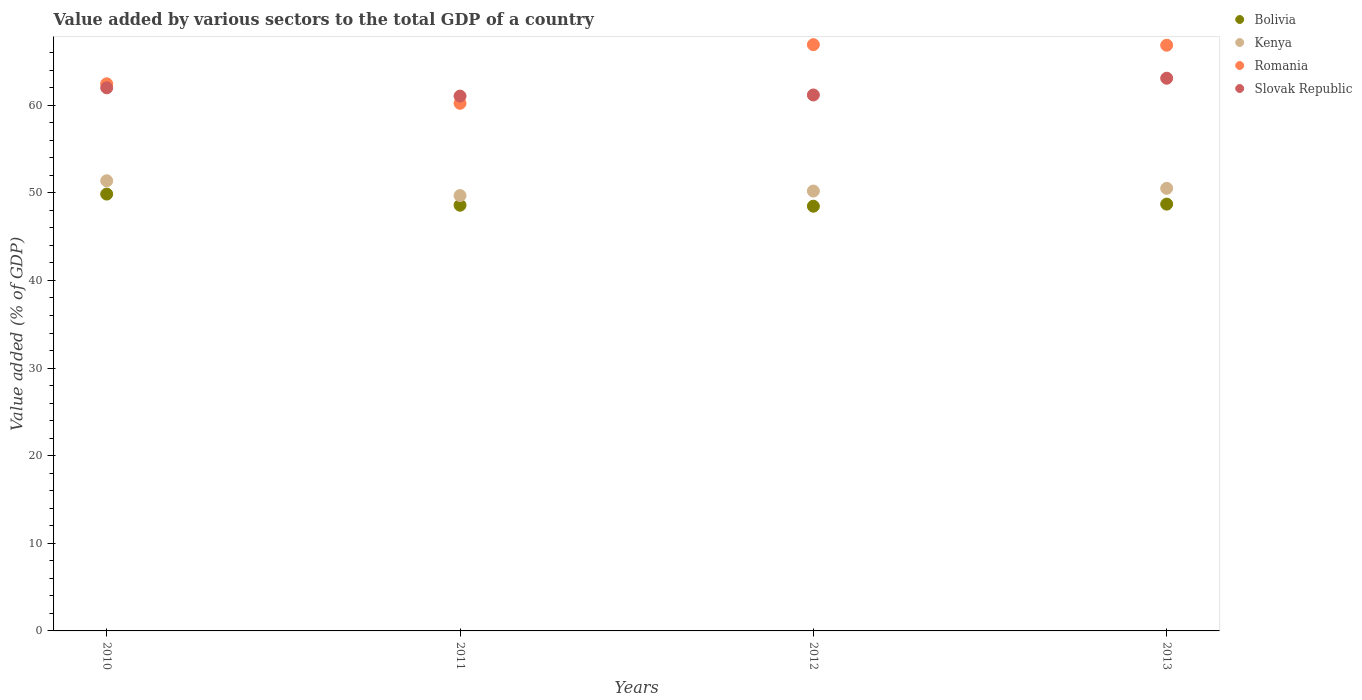How many different coloured dotlines are there?
Provide a succinct answer. 4. Is the number of dotlines equal to the number of legend labels?
Offer a very short reply. Yes. What is the value added by various sectors to the total GDP in Kenya in 2011?
Your response must be concise. 49.68. Across all years, what is the maximum value added by various sectors to the total GDP in Kenya?
Offer a terse response. 51.38. Across all years, what is the minimum value added by various sectors to the total GDP in Kenya?
Offer a very short reply. 49.68. In which year was the value added by various sectors to the total GDP in Slovak Republic maximum?
Provide a short and direct response. 2013. In which year was the value added by various sectors to the total GDP in Slovak Republic minimum?
Provide a short and direct response. 2011. What is the total value added by various sectors to the total GDP in Kenya in the graph?
Provide a short and direct response. 201.77. What is the difference between the value added by various sectors to the total GDP in Bolivia in 2011 and that in 2013?
Keep it short and to the point. -0.12. What is the difference between the value added by various sectors to the total GDP in Kenya in 2011 and the value added by various sectors to the total GDP in Romania in 2010?
Offer a very short reply. -12.75. What is the average value added by various sectors to the total GDP in Kenya per year?
Offer a terse response. 50.44. In the year 2010, what is the difference between the value added by various sectors to the total GDP in Romania and value added by various sectors to the total GDP in Kenya?
Offer a very short reply. 11.06. What is the ratio of the value added by various sectors to the total GDP in Romania in 2011 to that in 2013?
Ensure brevity in your answer.  0.9. Is the value added by various sectors to the total GDP in Slovak Republic in 2011 less than that in 2012?
Provide a succinct answer. Yes. Is the difference between the value added by various sectors to the total GDP in Romania in 2012 and 2013 greater than the difference between the value added by various sectors to the total GDP in Kenya in 2012 and 2013?
Offer a terse response. Yes. What is the difference between the highest and the second highest value added by various sectors to the total GDP in Bolivia?
Provide a short and direct response. 1.15. What is the difference between the highest and the lowest value added by various sectors to the total GDP in Kenya?
Offer a very short reply. 1.69. In how many years, is the value added by various sectors to the total GDP in Romania greater than the average value added by various sectors to the total GDP in Romania taken over all years?
Make the answer very short. 2. Is it the case that in every year, the sum of the value added by various sectors to the total GDP in Slovak Republic and value added by various sectors to the total GDP in Kenya  is greater than the value added by various sectors to the total GDP in Romania?
Keep it short and to the point. Yes. Does the value added by various sectors to the total GDP in Slovak Republic monotonically increase over the years?
Your response must be concise. No. How many dotlines are there?
Keep it short and to the point. 4. What is the difference between two consecutive major ticks on the Y-axis?
Your response must be concise. 10. Does the graph contain any zero values?
Your response must be concise. No. Where does the legend appear in the graph?
Offer a very short reply. Top right. How many legend labels are there?
Your response must be concise. 4. What is the title of the graph?
Your answer should be very brief. Value added by various sectors to the total GDP of a country. What is the label or title of the Y-axis?
Your answer should be compact. Value added (% of GDP). What is the Value added (% of GDP) of Bolivia in 2010?
Provide a short and direct response. 49.86. What is the Value added (% of GDP) in Kenya in 2010?
Your answer should be very brief. 51.38. What is the Value added (% of GDP) of Romania in 2010?
Your answer should be compact. 62.44. What is the Value added (% of GDP) of Slovak Republic in 2010?
Make the answer very short. 61.98. What is the Value added (% of GDP) of Bolivia in 2011?
Your answer should be very brief. 48.58. What is the Value added (% of GDP) in Kenya in 2011?
Give a very brief answer. 49.68. What is the Value added (% of GDP) of Romania in 2011?
Offer a terse response. 60.21. What is the Value added (% of GDP) of Slovak Republic in 2011?
Provide a short and direct response. 61.04. What is the Value added (% of GDP) in Bolivia in 2012?
Offer a terse response. 48.47. What is the Value added (% of GDP) of Kenya in 2012?
Offer a very short reply. 50.2. What is the Value added (% of GDP) of Romania in 2012?
Ensure brevity in your answer.  66.91. What is the Value added (% of GDP) in Slovak Republic in 2012?
Make the answer very short. 61.17. What is the Value added (% of GDP) in Bolivia in 2013?
Give a very brief answer. 48.71. What is the Value added (% of GDP) in Kenya in 2013?
Your answer should be very brief. 50.51. What is the Value added (% of GDP) in Romania in 2013?
Your response must be concise. 66.84. What is the Value added (% of GDP) of Slovak Republic in 2013?
Your answer should be compact. 63.08. Across all years, what is the maximum Value added (% of GDP) in Bolivia?
Keep it short and to the point. 49.86. Across all years, what is the maximum Value added (% of GDP) of Kenya?
Offer a very short reply. 51.38. Across all years, what is the maximum Value added (% of GDP) in Romania?
Ensure brevity in your answer.  66.91. Across all years, what is the maximum Value added (% of GDP) of Slovak Republic?
Your answer should be very brief. 63.08. Across all years, what is the minimum Value added (% of GDP) of Bolivia?
Provide a succinct answer. 48.47. Across all years, what is the minimum Value added (% of GDP) of Kenya?
Offer a terse response. 49.68. Across all years, what is the minimum Value added (% of GDP) in Romania?
Keep it short and to the point. 60.21. Across all years, what is the minimum Value added (% of GDP) of Slovak Republic?
Ensure brevity in your answer.  61.04. What is the total Value added (% of GDP) in Bolivia in the graph?
Your answer should be very brief. 195.62. What is the total Value added (% of GDP) of Kenya in the graph?
Provide a succinct answer. 201.77. What is the total Value added (% of GDP) in Romania in the graph?
Keep it short and to the point. 256.41. What is the total Value added (% of GDP) in Slovak Republic in the graph?
Provide a short and direct response. 247.27. What is the difference between the Value added (% of GDP) in Bolivia in 2010 and that in 2011?
Offer a terse response. 1.27. What is the difference between the Value added (% of GDP) of Kenya in 2010 and that in 2011?
Ensure brevity in your answer.  1.69. What is the difference between the Value added (% of GDP) of Romania in 2010 and that in 2011?
Make the answer very short. 2.23. What is the difference between the Value added (% of GDP) of Slovak Republic in 2010 and that in 2011?
Give a very brief answer. 0.94. What is the difference between the Value added (% of GDP) of Bolivia in 2010 and that in 2012?
Offer a terse response. 1.39. What is the difference between the Value added (% of GDP) in Kenya in 2010 and that in 2012?
Offer a terse response. 1.17. What is the difference between the Value added (% of GDP) in Romania in 2010 and that in 2012?
Give a very brief answer. -4.47. What is the difference between the Value added (% of GDP) of Slovak Republic in 2010 and that in 2012?
Ensure brevity in your answer.  0.82. What is the difference between the Value added (% of GDP) in Bolivia in 2010 and that in 2013?
Keep it short and to the point. 1.15. What is the difference between the Value added (% of GDP) in Kenya in 2010 and that in 2013?
Your answer should be compact. 0.86. What is the difference between the Value added (% of GDP) in Romania in 2010 and that in 2013?
Give a very brief answer. -4.4. What is the difference between the Value added (% of GDP) in Slovak Republic in 2010 and that in 2013?
Provide a short and direct response. -1.09. What is the difference between the Value added (% of GDP) of Bolivia in 2011 and that in 2012?
Your answer should be very brief. 0.11. What is the difference between the Value added (% of GDP) in Kenya in 2011 and that in 2012?
Ensure brevity in your answer.  -0.52. What is the difference between the Value added (% of GDP) in Romania in 2011 and that in 2012?
Keep it short and to the point. -6.69. What is the difference between the Value added (% of GDP) of Slovak Republic in 2011 and that in 2012?
Offer a very short reply. -0.13. What is the difference between the Value added (% of GDP) in Bolivia in 2011 and that in 2013?
Offer a very short reply. -0.12. What is the difference between the Value added (% of GDP) of Kenya in 2011 and that in 2013?
Your answer should be compact. -0.83. What is the difference between the Value added (% of GDP) of Romania in 2011 and that in 2013?
Offer a terse response. -6.63. What is the difference between the Value added (% of GDP) in Slovak Republic in 2011 and that in 2013?
Your response must be concise. -2.04. What is the difference between the Value added (% of GDP) in Bolivia in 2012 and that in 2013?
Provide a short and direct response. -0.24. What is the difference between the Value added (% of GDP) of Kenya in 2012 and that in 2013?
Your answer should be compact. -0.31. What is the difference between the Value added (% of GDP) in Romania in 2012 and that in 2013?
Your answer should be compact. 0.07. What is the difference between the Value added (% of GDP) of Slovak Republic in 2012 and that in 2013?
Offer a very short reply. -1.91. What is the difference between the Value added (% of GDP) in Bolivia in 2010 and the Value added (% of GDP) in Kenya in 2011?
Your response must be concise. 0.17. What is the difference between the Value added (% of GDP) in Bolivia in 2010 and the Value added (% of GDP) in Romania in 2011?
Provide a succinct answer. -10.36. What is the difference between the Value added (% of GDP) in Bolivia in 2010 and the Value added (% of GDP) in Slovak Republic in 2011?
Provide a short and direct response. -11.18. What is the difference between the Value added (% of GDP) of Kenya in 2010 and the Value added (% of GDP) of Romania in 2011?
Your answer should be compact. -8.84. What is the difference between the Value added (% of GDP) in Kenya in 2010 and the Value added (% of GDP) in Slovak Republic in 2011?
Keep it short and to the point. -9.66. What is the difference between the Value added (% of GDP) in Romania in 2010 and the Value added (% of GDP) in Slovak Republic in 2011?
Give a very brief answer. 1.4. What is the difference between the Value added (% of GDP) in Bolivia in 2010 and the Value added (% of GDP) in Kenya in 2012?
Provide a short and direct response. -0.35. What is the difference between the Value added (% of GDP) in Bolivia in 2010 and the Value added (% of GDP) in Romania in 2012?
Provide a succinct answer. -17.05. What is the difference between the Value added (% of GDP) of Bolivia in 2010 and the Value added (% of GDP) of Slovak Republic in 2012?
Your response must be concise. -11.31. What is the difference between the Value added (% of GDP) in Kenya in 2010 and the Value added (% of GDP) in Romania in 2012?
Your answer should be very brief. -15.53. What is the difference between the Value added (% of GDP) in Kenya in 2010 and the Value added (% of GDP) in Slovak Republic in 2012?
Give a very brief answer. -9.79. What is the difference between the Value added (% of GDP) in Romania in 2010 and the Value added (% of GDP) in Slovak Republic in 2012?
Your response must be concise. 1.27. What is the difference between the Value added (% of GDP) in Bolivia in 2010 and the Value added (% of GDP) in Kenya in 2013?
Offer a very short reply. -0.65. What is the difference between the Value added (% of GDP) of Bolivia in 2010 and the Value added (% of GDP) of Romania in 2013?
Provide a succinct answer. -16.99. What is the difference between the Value added (% of GDP) in Bolivia in 2010 and the Value added (% of GDP) in Slovak Republic in 2013?
Offer a very short reply. -13.22. What is the difference between the Value added (% of GDP) in Kenya in 2010 and the Value added (% of GDP) in Romania in 2013?
Offer a very short reply. -15.47. What is the difference between the Value added (% of GDP) in Kenya in 2010 and the Value added (% of GDP) in Slovak Republic in 2013?
Your answer should be very brief. -11.7. What is the difference between the Value added (% of GDP) in Romania in 2010 and the Value added (% of GDP) in Slovak Republic in 2013?
Your answer should be compact. -0.64. What is the difference between the Value added (% of GDP) of Bolivia in 2011 and the Value added (% of GDP) of Kenya in 2012?
Keep it short and to the point. -1.62. What is the difference between the Value added (% of GDP) in Bolivia in 2011 and the Value added (% of GDP) in Romania in 2012?
Provide a succinct answer. -18.32. What is the difference between the Value added (% of GDP) of Bolivia in 2011 and the Value added (% of GDP) of Slovak Republic in 2012?
Your response must be concise. -12.58. What is the difference between the Value added (% of GDP) in Kenya in 2011 and the Value added (% of GDP) in Romania in 2012?
Give a very brief answer. -17.22. What is the difference between the Value added (% of GDP) in Kenya in 2011 and the Value added (% of GDP) in Slovak Republic in 2012?
Your response must be concise. -11.48. What is the difference between the Value added (% of GDP) of Romania in 2011 and the Value added (% of GDP) of Slovak Republic in 2012?
Provide a short and direct response. -0.95. What is the difference between the Value added (% of GDP) in Bolivia in 2011 and the Value added (% of GDP) in Kenya in 2013?
Keep it short and to the point. -1.93. What is the difference between the Value added (% of GDP) of Bolivia in 2011 and the Value added (% of GDP) of Romania in 2013?
Your response must be concise. -18.26. What is the difference between the Value added (% of GDP) in Bolivia in 2011 and the Value added (% of GDP) in Slovak Republic in 2013?
Your response must be concise. -14.49. What is the difference between the Value added (% of GDP) in Kenya in 2011 and the Value added (% of GDP) in Romania in 2013?
Provide a succinct answer. -17.16. What is the difference between the Value added (% of GDP) in Kenya in 2011 and the Value added (% of GDP) in Slovak Republic in 2013?
Offer a terse response. -13.39. What is the difference between the Value added (% of GDP) of Romania in 2011 and the Value added (% of GDP) of Slovak Republic in 2013?
Ensure brevity in your answer.  -2.86. What is the difference between the Value added (% of GDP) in Bolivia in 2012 and the Value added (% of GDP) in Kenya in 2013?
Offer a very short reply. -2.04. What is the difference between the Value added (% of GDP) of Bolivia in 2012 and the Value added (% of GDP) of Romania in 2013?
Offer a very short reply. -18.37. What is the difference between the Value added (% of GDP) of Bolivia in 2012 and the Value added (% of GDP) of Slovak Republic in 2013?
Your answer should be compact. -14.61. What is the difference between the Value added (% of GDP) in Kenya in 2012 and the Value added (% of GDP) in Romania in 2013?
Provide a succinct answer. -16.64. What is the difference between the Value added (% of GDP) in Kenya in 2012 and the Value added (% of GDP) in Slovak Republic in 2013?
Make the answer very short. -12.87. What is the difference between the Value added (% of GDP) of Romania in 2012 and the Value added (% of GDP) of Slovak Republic in 2013?
Keep it short and to the point. 3.83. What is the average Value added (% of GDP) in Bolivia per year?
Your answer should be very brief. 48.91. What is the average Value added (% of GDP) in Kenya per year?
Provide a succinct answer. 50.44. What is the average Value added (% of GDP) in Romania per year?
Your answer should be compact. 64.1. What is the average Value added (% of GDP) of Slovak Republic per year?
Provide a short and direct response. 61.82. In the year 2010, what is the difference between the Value added (% of GDP) in Bolivia and Value added (% of GDP) in Kenya?
Provide a short and direct response. -1.52. In the year 2010, what is the difference between the Value added (% of GDP) of Bolivia and Value added (% of GDP) of Romania?
Your answer should be very brief. -12.58. In the year 2010, what is the difference between the Value added (% of GDP) of Bolivia and Value added (% of GDP) of Slovak Republic?
Ensure brevity in your answer.  -12.13. In the year 2010, what is the difference between the Value added (% of GDP) of Kenya and Value added (% of GDP) of Romania?
Give a very brief answer. -11.06. In the year 2010, what is the difference between the Value added (% of GDP) in Kenya and Value added (% of GDP) in Slovak Republic?
Offer a very short reply. -10.61. In the year 2010, what is the difference between the Value added (% of GDP) in Romania and Value added (% of GDP) in Slovak Republic?
Make the answer very short. 0.46. In the year 2011, what is the difference between the Value added (% of GDP) of Bolivia and Value added (% of GDP) of Kenya?
Your response must be concise. -1.1. In the year 2011, what is the difference between the Value added (% of GDP) of Bolivia and Value added (% of GDP) of Romania?
Make the answer very short. -11.63. In the year 2011, what is the difference between the Value added (% of GDP) of Bolivia and Value added (% of GDP) of Slovak Republic?
Keep it short and to the point. -12.46. In the year 2011, what is the difference between the Value added (% of GDP) in Kenya and Value added (% of GDP) in Romania?
Make the answer very short. -10.53. In the year 2011, what is the difference between the Value added (% of GDP) of Kenya and Value added (% of GDP) of Slovak Republic?
Provide a short and direct response. -11.35. In the year 2011, what is the difference between the Value added (% of GDP) in Romania and Value added (% of GDP) in Slovak Republic?
Your answer should be compact. -0.83. In the year 2012, what is the difference between the Value added (% of GDP) in Bolivia and Value added (% of GDP) in Kenya?
Provide a short and direct response. -1.73. In the year 2012, what is the difference between the Value added (% of GDP) of Bolivia and Value added (% of GDP) of Romania?
Keep it short and to the point. -18.44. In the year 2012, what is the difference between the Value added (% of GDP) of Bolivia and Value added (% of GDP) of Slovak Republic?
Your answer should be very brief. -12.69. In the year 2012, what is the difference between the Value added (% of GDP) of Kenya and Value added (% of GDP) of Romania?
Offer a very short reply. -16.71. In the year 2012, what is the difference between the Value added (% of GDP) of Kenya and Value added (% of GDP) of Slovak Republic?
Offer a very short reply. -10.96. In the year 2012, what is the difference between the Value added (% of GDP) in Romania and Value added (% of GDP) in Slovak Republic?
Your response must be concise. 5.74. In the year 2013, what is the difference between the Value added (% of GDP) of Bolivia and Value added (% of GDP) of Kenya?
Offer a very short reply. -1.8. In the year 2013, what is the difference between the Value added (% of GDP) in Bolivia and Value added (% of GDP) in Romania?
Offer a very short reply. -18.13. In the year 2013, what is the difference between the Value added (% of GDP) in Bolivia and Value added (% of GDP) in Slovak Republic?
Your answer should be compact. -14.37. In the year 2013, what is the difference between the Value added (% of GDP) in Kenya and Value added (% of GDP) in Romania?
Offer a very short reply. -16.33. In the year 2013, what is the difference between the Value added (% of GDP) in Kenya and Value added (% of GDP) in Slovak Republic?
Provide a short and direct response. -12.57. In the year 2013, what is the difference between the Value added (% of GDP) of Romania and Value added (% of GDP) of Slovak Republic?
Offer a terse response. 3.77. What is the ratio of the Value added (% of GDP) of Bolivia in 2010 to that in 2011?
Provide a short and direct response. 1.03. What is the ratio of the Value added (% of GDP) in Kenya in 2010 to that in 2011?
Give a very brief answer. 1.03. What is the ratio of the Value added (% of GDP) in Romania in 2010 to that in 2011?
Offer a terse response. 1.04. What is the ratio of the Value added (% of GDP) in Slovak Republic in 2010 to that in 2011?
Offer a very short reply. 1.02. What is the ratio of the Value added (% of GDP) in Bolivia in 2010 to that in 2012?
Your answer should be compact. 1.03. What is the ratio of the Value added (% of GDP) of Kenya in 2010 to that in 2012?
Your answer should be very brief. 1.02. What is the ratio of the Value added (% of GDP) of Romania in 2010 to that in 2012?
Your response must be concise. 0.93. What is the ratio of the Value added (% of GDP) in Slovak Republic in 2010 to that in 2012?
Provide a short and direct response. 1.01. What is the ratio of the Value added (% of GDP) in Bolivia in 2010 to that in 2013?
Ensure brevity in your answer.  1.02. What is the ratio of the Value added (% of GDP) of Kenya in 2010 to that in 2013?
Make the answer very short. 1.02. What is the ratio of the Value added (% of GDP) in Romania in 2010 to that in 2013?
Offer a terse response. 0.93. What is the ratio of the Value added (% of GDP) of Slovak Republic in 2010 to that in 2013?
Offer a very short reply. 0.98. What is the ratio of the Value added (% of GDP) in Bolivia in 2011 to that in 2012?
Give a very brief answer. 1. What is the ratio of the Value added (% of GDP) of Kenya in 2011 to that in 2012?
Your answer should be compact. 0.99. What is the ratio of the Value added (% of GDP) in Romania in 2011 to that in 2012?
Make the answer very short. 0.9. What is the ratio of the Value added (% of GDP) of Slovak Republic in 2011 to that in 2012?
Your answer should be compact. 1. What is the ratio of the Value added (% of GDP) of Bolivia in 2011 to that in 2013?
Offer a terse response. 1. What is the ratio of the Value added (% of GDP) of Kenya in 2011 to that in 2013?
Offer a terse response. 0.98. What is the ratio of the Value added (% of GDP) of Romania in 2011 to that in 2013?
Offer a very short reply. 0.9. What is the ratio of the Value added (% of GDP) in Slovak Republic in 2011 to that in 2013?
Offer a very short reply. 0.97. What is the ratio of the Value added (% of GDP) in Bolivia in 2012 to that in 2013?
Provide a succinct answer. 1. What is the ratio of the Value added (% of GDP) in Kenya in 2012 to that in 2013?
Ensure brevity in your answer.  0.99. What is the ratio of the Value added (% of GDP) of Slovak Republic in 2012 to that in 2013?
Your answer should be very brief. 0.97. What is the difference between the highest and the second highest Value added (% of GDP) of Bolivia?
Offer a terse response. 1.15. What is the difference between the highest and the second highest Value added (% of GDP) in Kenya?
Give a very brief answer. 0.86. What is the difference between the highest and the second highest Value added (% of GDP) in Romania?
Your answer should be compact. 0.07. What is the difference between the highest and the second highest Value added (% of GDP) in Slovak Republic?
Provide a succinct answer. 1.09. What is the difference between the highest and the lowest Value added (% of GDP) in Bolivia?
Keep it short and to the point. 1.39. What is the difference between the highest and the lowest Value added (% of GDP) of Kenya?
Ensure brevity in your answer.  1.69. What is the difference between the highest and the lowest Value added (% of GDP) in Romania?
Offer a terse response. 6.69. What is the difference between the highest and the lowest Value added (% of GDP) in Slovak Republic?
Provide a short and direct response. 2.04. 